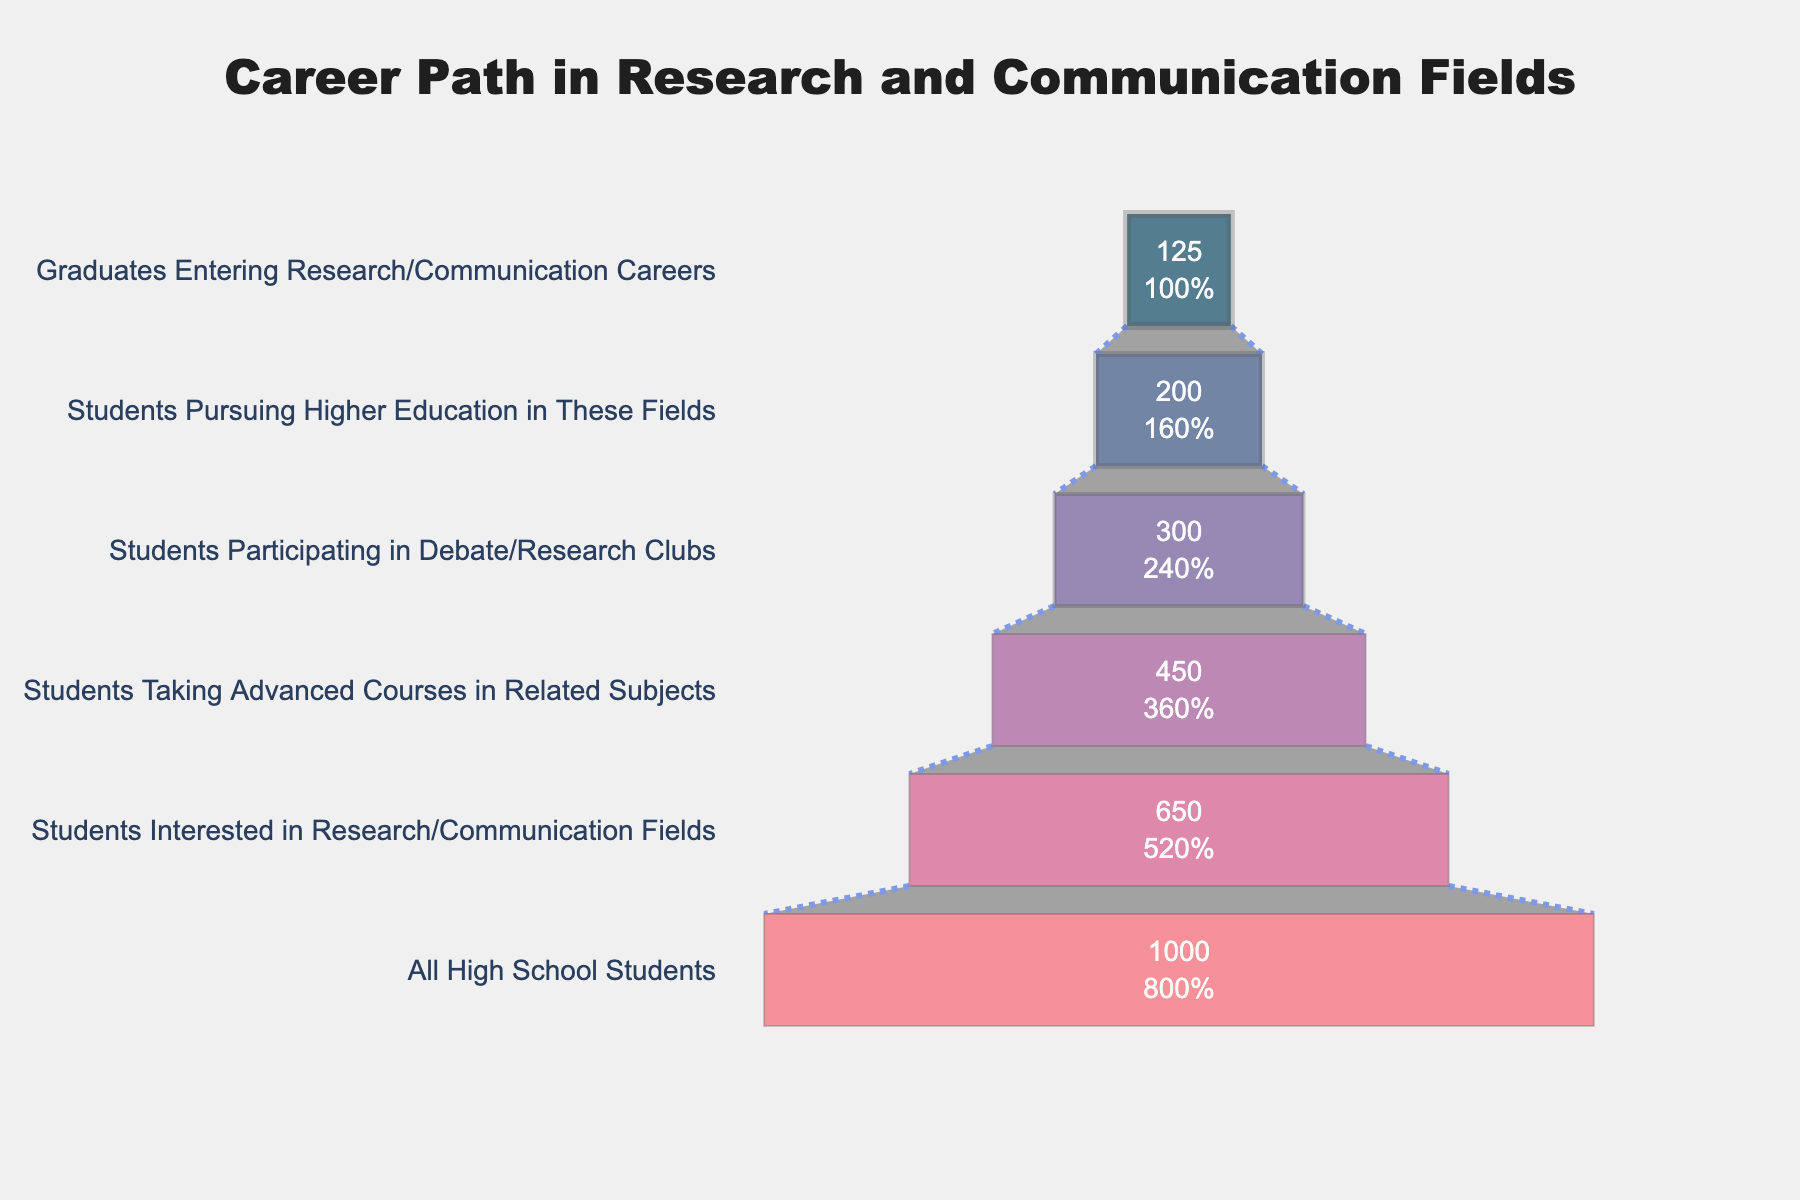What's the title of the chart? The title is usually displayed at the top of the chart. In this case, it's a specific text that provides an overview of the chart's content.
Answer: Career Path in Research and Communication Fields How many stages are there in the funnel chart? By counting the number of distinct segments or layers in the funnel, we can determine the number of stages. Each stage represents a different level in the career path.
Answer: 6 Which stage has the highest number of students? By looking at the funnel, the widest (or first) segment at the top will have the highest number of students.
Answer: All High School Students What percentage of high school students are interested in research/communication fields? This percentage is displayed in the second stage of the funnel chart. It shows the ratio of students interested in research/communication fields compared to the total number of high school students.
Answer: 65% How many students are left between the "Students Participating in Debate/Research Clubs" stage and the "Graduates Entering Research/Communication Careers" stage? Subtract the number of students in the final stage from the number of students in the "Students Participating in Debate/Research Clubs" stage. 300 - 125 = 175
Answer: 175 What is the difference in the number of students between those interested in the fields and those taking advanced courses? Subtract the number of students taking advanced courses from those interested in these fields. 650 - 450 = 200
Answer: 200 Which stage shows a 50% decrease in student numbers? By reviewing the stages, observe where the number of students reduces by half. The transition from 450 to 300 represents a significant drop but not exactly 50%. The correct deduction is from 200 to 125, which is also not exactly 50%. This appears to be a trick question.
Answer: None What percentage of students pursue higher education in these fields compared to those taking advanced courses? Divide the number of students pursuing higher education by the number taking advanced courses, and multiply by 100. (200 / 450) * 100 = 44.44%
Answer: 44.44% What is the conversion rate from "Students Interested in Research/Communication Fields" to "Graduates Entering Research/Communication Careers"? Divide the number of graduates entering research/communication careers by the number of students interested in these fields, then multiply by 100. (125 / 650) * 100 ≈ 19.23%
Answer: 19.23% Which stage shows the least percentage loss compared to the previous stage? Calculate the percentage difference for each transition and identify the least. (300 to 200) shows a loss of (300-200)/300*100 = 33.33%.
Answer: Students Pursuing Higher Education in These Fields 